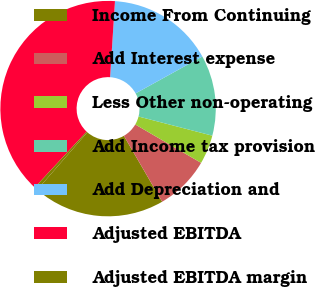Convert chart to OTSL. <chart><loc_0><loc_0><loc_500><loc_500><pie_chart><fcel>Income From Continuing<fcel>Add Interest expense<fcel>Less Other non-operating<fcel>Add Income tax provision<fcel>Add Depreciation and<fcel>Adjusted EBITDA<fcel>Adjusted EBITDA margin<nl><fcel>19.8%<fcel>8.22%<fcel>4.36%<fcel>12.08%<fcel>15.94%<fcel>39.1%<fcel>0.5%<nl></chart> 